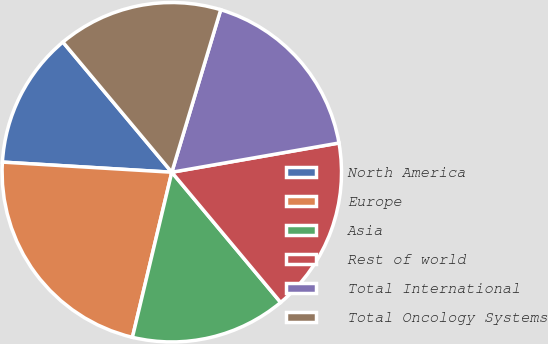Convert chart. <chart><loc_0><loc_0><loc_500><loc_500><pie_chart><fcel>North America<fcel>Europe<fcel>Asia<fcel>Rest of world<fcel>Total International<fcel>Total Oncology Systems<nl><fcel>12.96%<fcel>22.22%<fcel>14.81%<fcel>16.67%<fcel>17.59%<fcel>15.74%<nl></chart> 